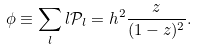Convert formula to latex. <formula><loc_0><loc_0><loc_500><loc_500>\phi \equiv \sum _ { l } l { \mathcal { P } } _ { l } = h ^ { 2 } \frac { z } { ( 1 - z ) ^ { 2 } } .</formula> 